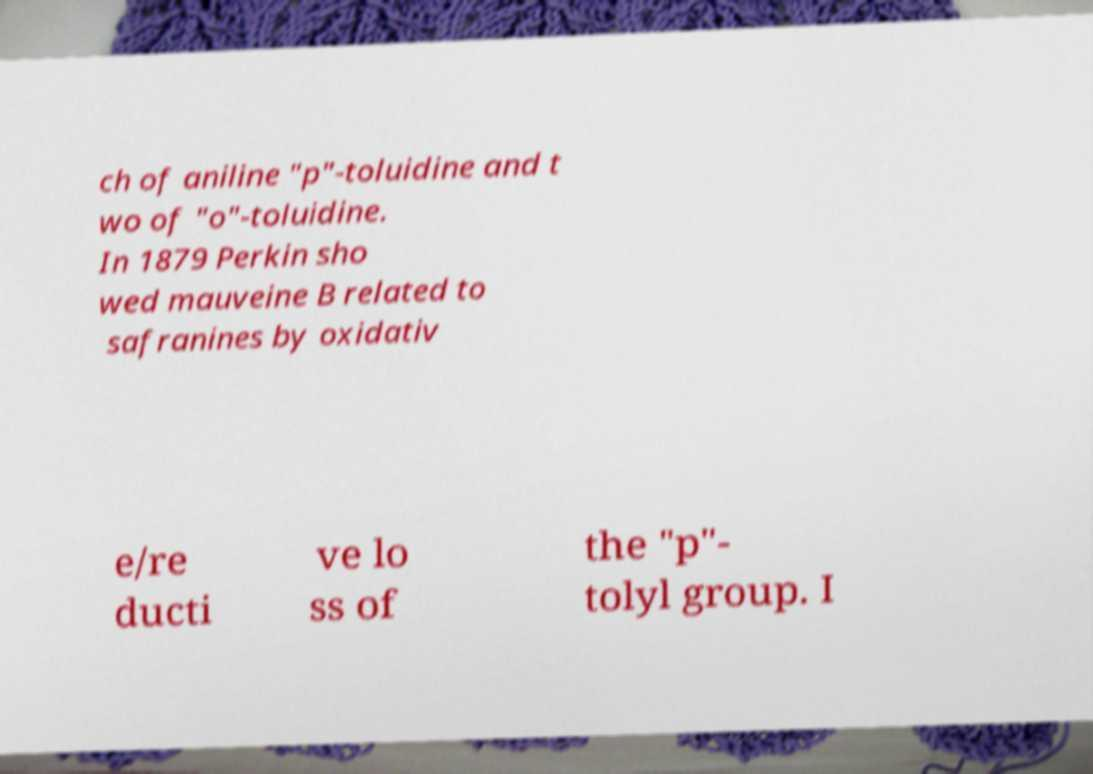For documentation purposes, I need the text within this image transcribed. Could you provide that? ch of aniline "p"-toluidine and t wo of "o"-toluidine. In 1879 Perkin sho wed mauveine B related to safranines by oxidativ e/re ducti ve lo ss of the "p"- tolyl group. I 